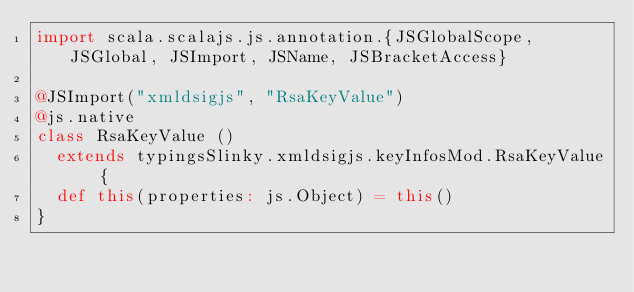Convert code to text. <code><loc_0><loc_0><loc_500><loc_500><_Scala_>import scala.scalajs.js.annotation.{JSGlobalScope, JSGlobal, JSImport, JSName, JSBracketAccess}

@JSImport("xmldsigjs", "RsaKeyValue")
@js.native
class RsaKeyValue ()
  extends typingsSlinky.xmldsigjs.keyInfosMod.RsaKeyValue {
  def this(properties: js.Object) = this()
}
</code> 